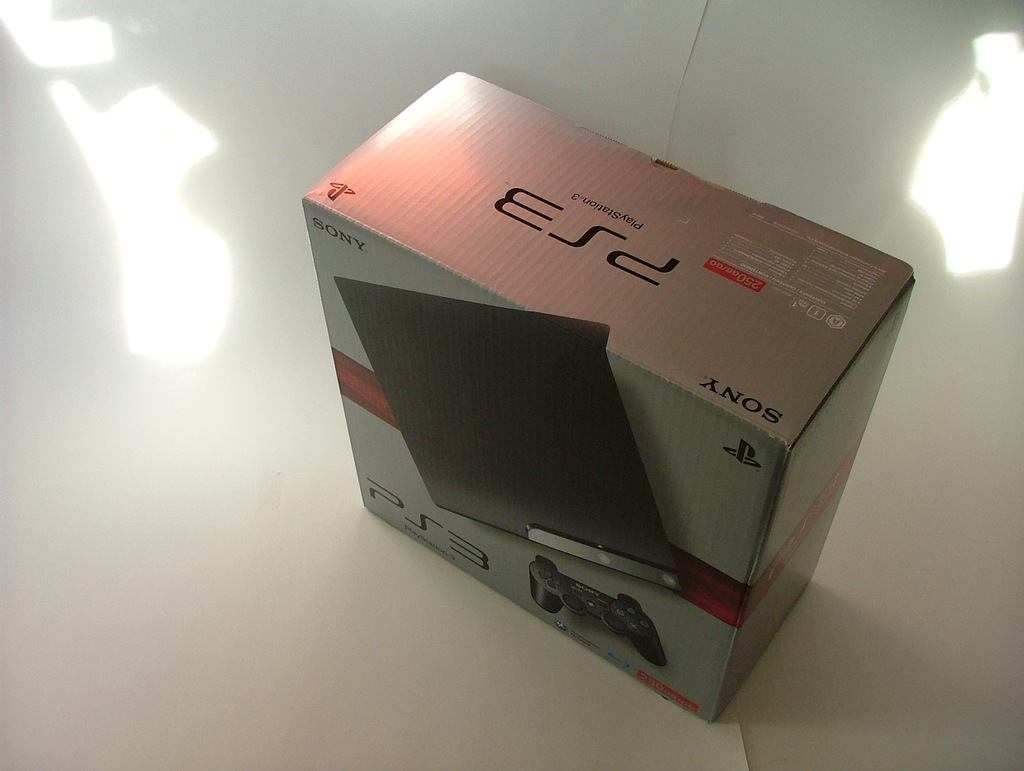Can you suggest what occasion or purpose might be fitting for purchasing this PS3? This brand new PlayStation 3 makes a perfect gift for gaming enthusiasts, particularly suitable for occasions like birthdays, holidays, or as a special reward. Its advanced gaming capabilities and entertainment features also make it ideal for someone looking to upgrade their existing gaming system or expand their home entertainment options. 